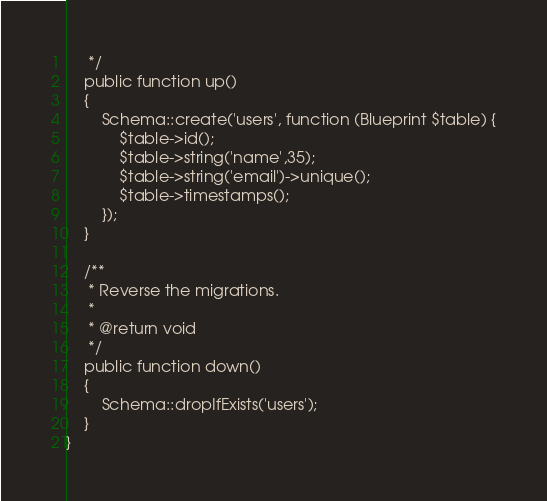Convert code to text. <code><loc_0><loc_0><loc_500><loc_500><_PHP_>     */
    public function up()
    {
        Schema::create('users', function (Blueprint $table) {
            $table->id();
            $table->string('name',35);
            $table->string('email')->unique();
            $table->timestamps();
        });
    }

    /**
     * Reverse the migrations.
     *
     * @return void
     */
    public function down()
    {
        Schema::dropIfExists('users');
    }
}
</code> 